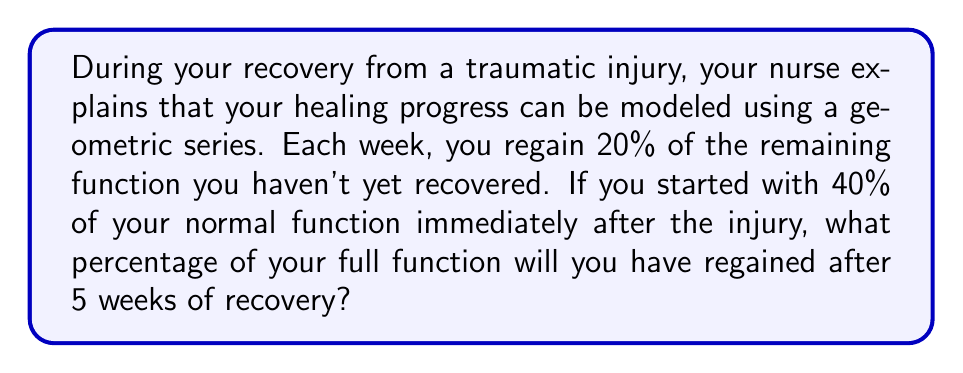Provide a solution to this math problem. Let's approach this step-by-step:

1) Let's define our initial conditions:
   - Initial function: 40% (or 0.4 in decimal form)
   - Recovery rate per week: 20% of remaining deficit (or 0.2)

2) We can model this as a geometric series where each term represents the additional function regained each week:

   $$a + ar + ar^2 + ar^3 + ar^4$$

   Where:
   $a$ = initial function regained in the first week
   $r$ = common ratio (percentage of remaining deficit recovered each week)

3) To find $a$:
   Remaining deficit after injury = 1 - 0.4 = 0.6
   $a = 0.6 * 0.2 = 0.12$

4) To find $r$:
   $r = 1 - 0.2 = 0.8$ (as we're looking at the remaining deficit each week)

5) Now, we can sum this geometric series for 5 terms:
   $$S_5 = \frac{a(1-r^5)}{1-r}$$

6) Substituting our values:
   $$S_5 = \frac{0.12(1-0.8^5)}{1-0.8}$$

7) Calculating:
   $$S_5 = \frac{0.12(1-0.32768)}{0.2} = 0.40339$$

8) This represents the additional function regained over 5 weeks. To get the total function, we add this to our initial 40%:

   Total function = 0.4 + 0.40339 = 0.80339

9) Converting to a percentage:
   0.80339 * 100 = 80.339%
Answer: After 5 weeks of recovery, you will have regained approximately 80.34% of your full function. 